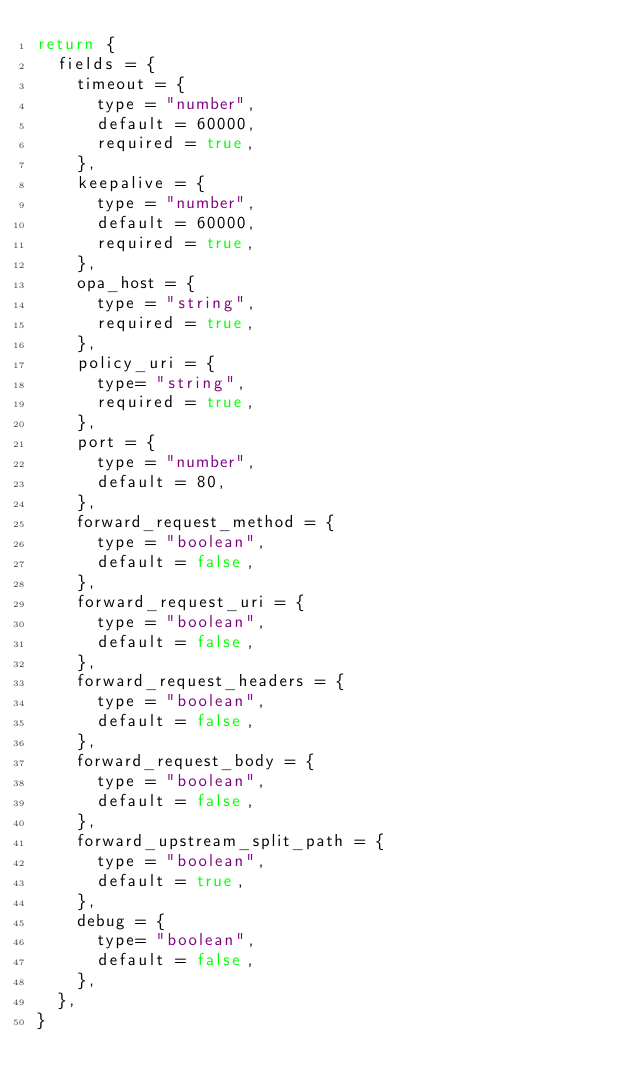<code> <loc_0><loc_0><loc_500><loc_500><_Lua_>return {
  fields = {
    timeout = {
      type = "number",
      default = 60000,
      required = true,
    },
    keepalive = {
      type = "number",
      default = 60000,
      required = true,
    },
    opa_host = {
      type = "string",
      required = true,
    },
    policy_uri = {
      type= "string",
      required = true,
    },
    port = {
      type = "number",
      default = 80,
    },
    forward_request_method = {
      type = "boolean",
      default = false,
    },
    forward_request_uri = {
      type = "boolean",
      default = false,
    },
    forward_request_headers = {
      type = "boolean",
      default = false,
    },
    forward_request_body = {
      type = "boolean",
      default = false,
    },
    forward_upstream_split_path = {
      type = "boolean",
      default = true,
    },
    debug = {
      type= "boolean",
      default = false,
    },
  },
}
</code> 